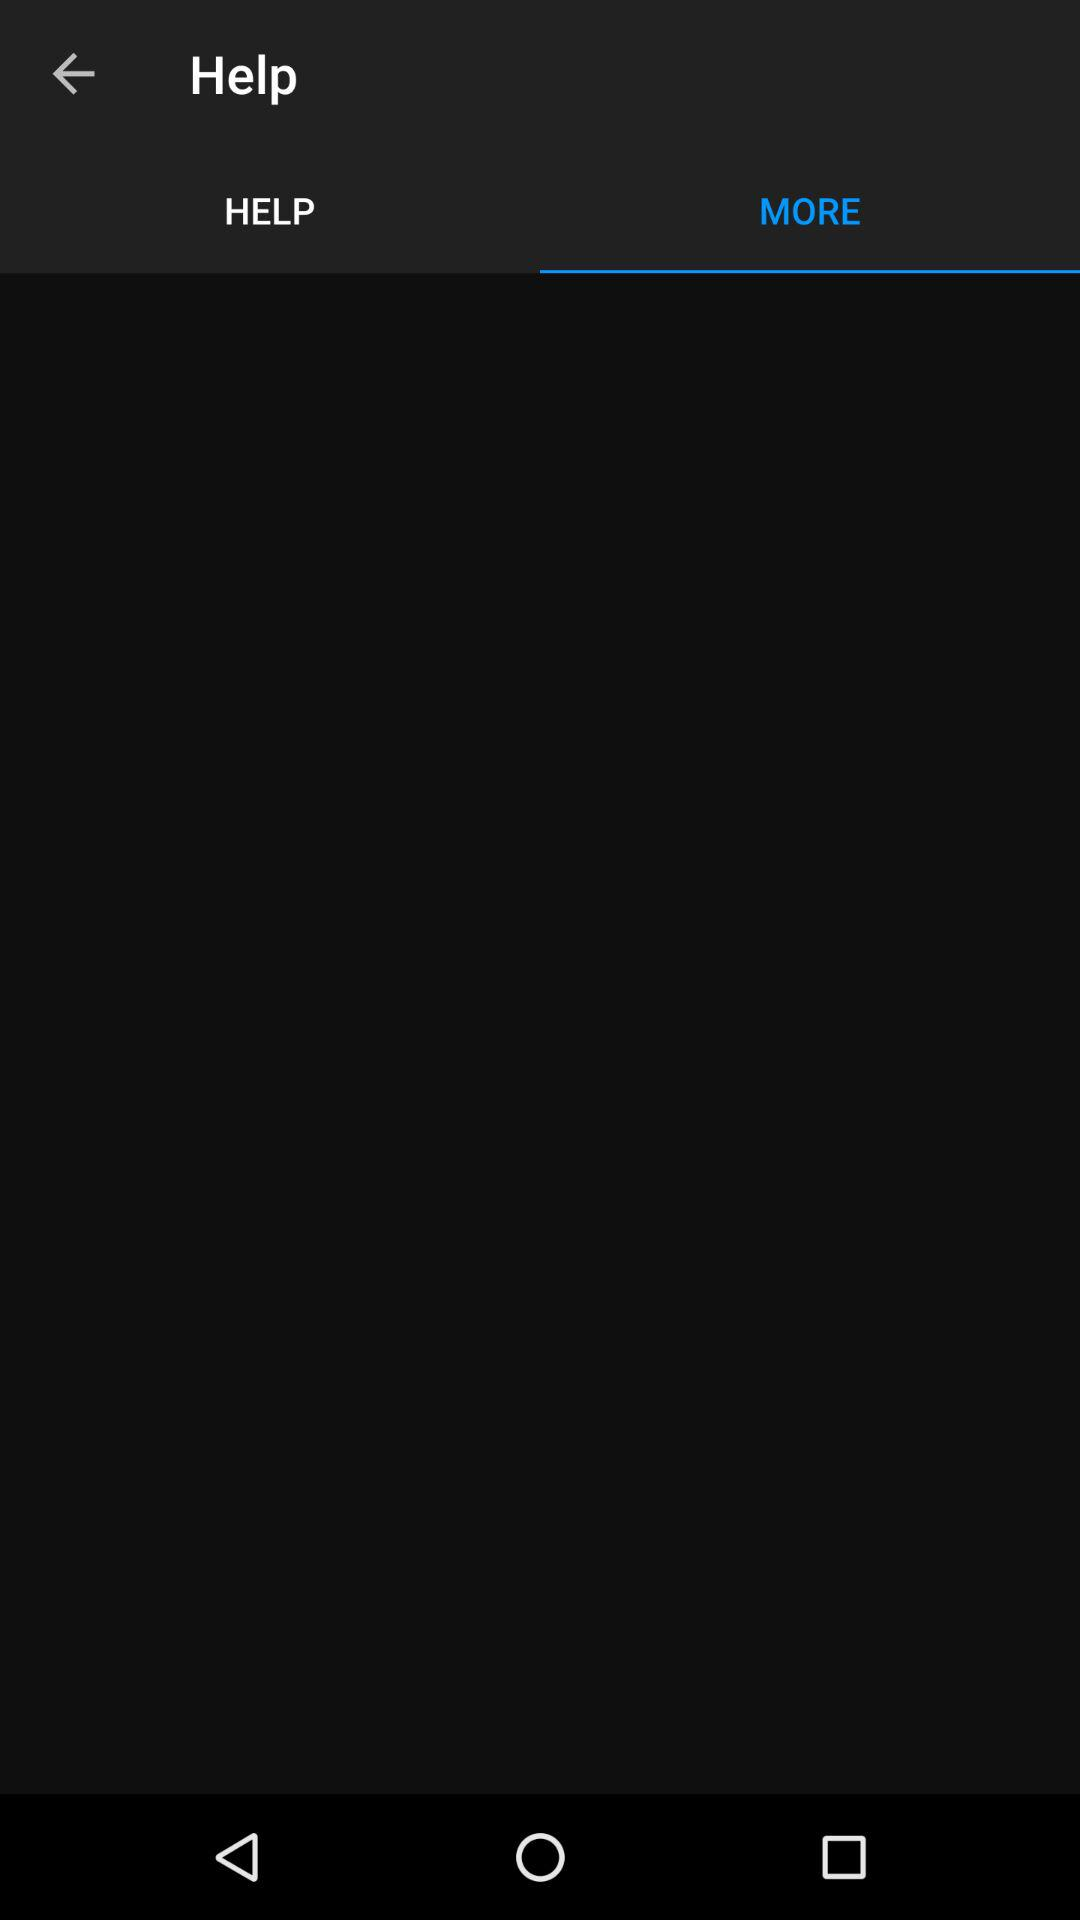Which tab is selected? The selected tab is "MORE". 